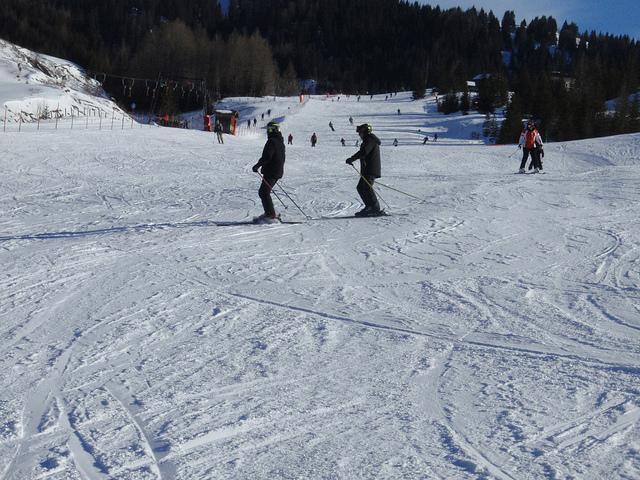Where can you most likely catch a ride nearby?
Make your selection from the four choices given to correctly answer the question.
Options: Ski lift, boat, elevator, ferris wheel. Ski lift. 